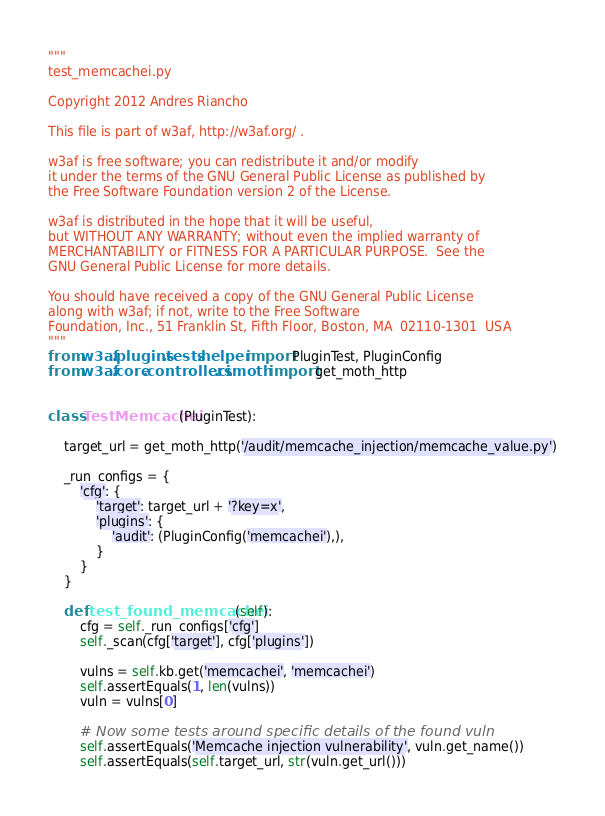<code> <loc_0><loc_0><loc_500><loc_500><_Python_>"""
test_memcachei.py

Copyright 2012 Andres Riancho

This file is part of w3af, http://w3af.org/ .

w3af is free software; you can redistribute it and/or modify
it under the terms of the GNU General Public License as published by
the Free Software Foundation version 2 of the License.

w3af is distributed in the hope that it will be useful,
but WITHOUT ANY WARRANTY; without even the implied warranty of
MERCHANTABILITY or FITNESS FOR A PARTICULAR PURPOSE.  See the
GNU General Public License for more details.

You should have received a copy of the GNU General Public License
along with w3af; if not, write to the Free Software
Foundation, Inc., 51 Franklin St, Fifth Floor, Boston, MA  02110-1301  USA
"""
from w3af.plugins.tests.helper import PluginTest, PluginConfig
from w3af.core.controllers.ci.moth import get_moth_http


class TestMemcachei(PluginTest):

    target_url = get_moth_http('/audit/memcache_injection/memcache_value.py')

    _run_configs = {
        'cfg': {
            'target': target_url + '?key=x',
            'plugins': {
                'audit': (PluginConfig('memcachei'),),
            }
        }
    }

    def test_found_memcachei(self):
        cfg = self._run_configs['cfg']
        self._scan(cfg['target'], cfg['plugins'])

        vulns = self.kb.get('memcachei', 'memcachei')
        self.assertEquals(1, len(vulns))
        vuln = vulns[0]

        # Now some tests around specific details of the found vuln
        self.assertEquals('Memcache injection vulnerability', vuln.get_name())
        self.assertEquals(self.target_url, str(vuln.get_url()))
</code> 